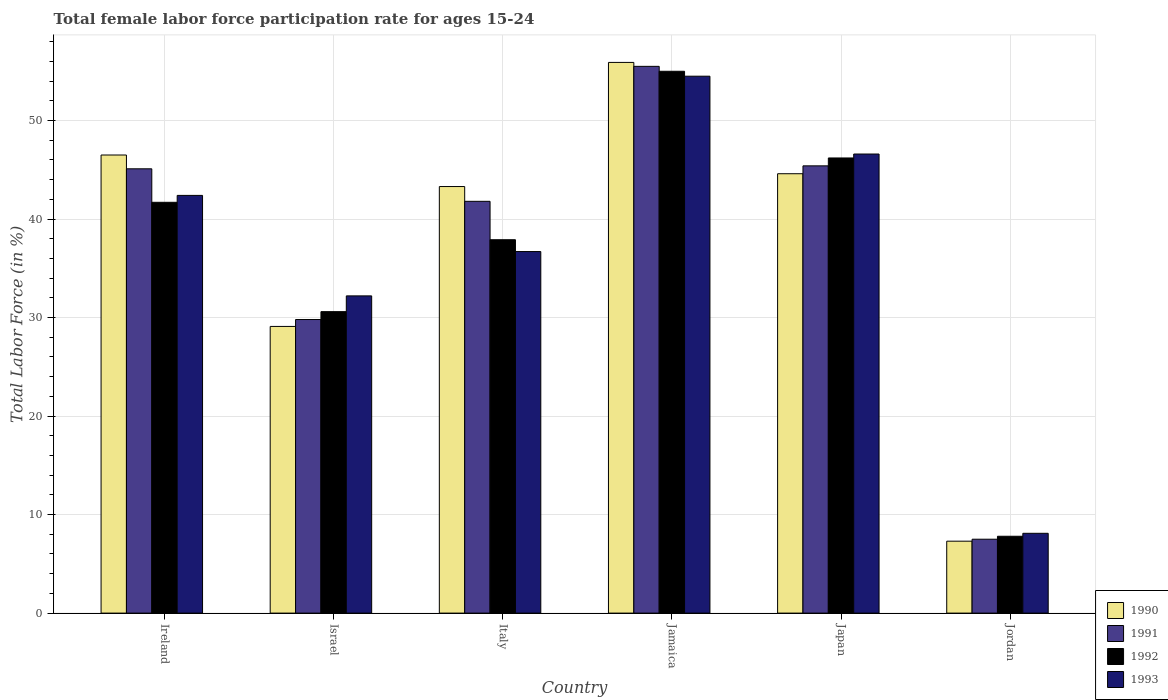How many different coloured bars are there?
Provide a succinct answer. 4. Are the number of bars per tick equal to the number of legend labels?
Ensure brevity in your answer.  Yes. Are the number of bars on each tick of the X-axis equal?
Provide a short and direct response. Yes. How many bars are there on the 5th tick from the right?
Offer a very short reply. 4. What is the label of the 4th group of bars from the left?
Your answer should be compact. Jamaica. What is the female labor force participation rate in 1991 in Japan?
Ensure brevity in your answer.  45.4. Across all countries, what is the maximum female labor force participation rate in 1993?
Your response must be concise. 54.5. Across all countries, what is the minimum female labor force participation rate in 1990?
Ensure brevity in your answer.  7.3. In which country was the female labor force participation rate in 1991 maximum?
Your answer should be compact. Jamaica. In which country was the female labor force participation rate in 1990 minimum?
Give a very brief answer. Jordan. What is the total female labor force participation rate in 1991 in the graph?
Make the answer very short. 225.1. What is the difference between the female labor force participation rate in 1991 in Italy and that in Japan?
Keep it short and to the point. -3.6. What is the difference between the female labor force participation rate in 1991 in Israel and the female labor force participation rate in 1990 in Italy?
Your response must be concise. -13.5. What is the average female labor force participation rate in 1991 per country?
Provide a short and direct response. 37.52. In how many countries, is the female labor force participation rate in 1991 greater than 14 %?
Offer a very short reply. 5. What is the ratio of the female labor force participation rate in 1990 in Ireland to that in Japan?
Give a very brief answer. 1.04. Is the female labor force participation rate in 1993 in Ireland less than that in Jamaica?
Keep it short and to the point. Yes. What is the difference between the highest and the second highest female labor force participation rate in 1993?
Make the answer very short. 4.2. In how many countries, is the female labor force participation rate in 1992 greater than the average female labor force participation rate in 1992 taken over all countries?
Offer a very short reply. 4. Is it the case that in every country, the sum of the female labor force participation rate in 1990 and female labor force participation rate in 1993 is greater than the sum of female labor force participation rate in 1992 and female labor force participation rate in 1991?
Keep it short and to the point. No. What does the 2nd bar from the left in Japan represents?
Your answer should be compact. 1991. How many bars are there?
Your answer should be very brief. 24. Are all the bars in the graph horizontal?
Offer a terse response. No. How many countries are there in the graph?
Ensure brevity in your answer.  6. What is the difference between two consecutive major ticks on the Y-axis?
Provide a short and direct response. 10. Are the values on the major ticks of Y-axis written in scientific E-notation?
Your response must be concise. No. Does the graph contain any zero values?
Keep it short and to the point. No. How are the legend labels stacked?
Your response must be concise. Vertical. What is the title of the graph?
Ensure brevity in your answer.  Total female labor force participation rate for ages 15-24. What is the Total Labor Force (in %) in 1990 in Ireland?
Make the answer very short. 46.5. What is the Total Labor Force (in %) in 1991 in Ireland?
Your response must be concise. 45.1. What is the Total Labor Force (in %) in 1992 in Ireland?
Your response must be concise. 41.7. What is the Total Labor Force (in %) of 1993 in Ireland?
Your answer should be compact. 42.4. What is the Total Labor Force (in %) of 1990 in Israel?
Give a very brief answer. 29.1. What is the Total Labor Force (in %) of 1991 in Israel?
Your answer should be compact. 29.8. What is the Total Labor Force (in %) in 1992 in Israel?
Offer a terse response. 30.6. What is the Total Labor Force (in %) in 1993 in Israel?
Your answer should be very brief. 32.2. What is the Total Labor Force (in %) of 1990 in Italy?
Offer a very short reply. 43.3. What is the Total Labor Force (in %) of 1991 in Italy?
Ensure brevity in your answer.  41.8. What is the Total Labor Force (in %) of 1992 in Italy?
Give a very brief answer. 37.9. What is the Total Labor Force (in %) in 1993 in Italy?
Ensure brevity in your answer.  36.7. What is the Total Labor Force (in %) of 1990 in Jamaica?
Make the answer very short. 55.9. What is the Total Labor Force (in %) of 1991 in Jamaica?
Offer a very short reply. 55.5. What is the Total Labor Force (in %) in 1992 in Jamaica?
Ensure brevity in your answer.  55. What is the Total Labor Force (in %) in 1993 in Jamaica?
Keep it short and to the point. 54.5. What is the Total Labor Force (in %) of 1990 in Japan?
Offer a terse response. 44.6. What is the Total Labor Force (in %) in 1991 in Japan?
Give a very brief answer. 45.4. What is the Total Labor Force (in %) of 1992 in Japan?
Ensure brevity in your answer.  46.2. What is the Total Labor Force (in %) in 1993 in Japan?
Offer a very short reply. 46.6. What is the Total Labor Force (in %) of 1990 in Jordan?
Give a very brief answer. 7.3. What is the Total Labor Force (in %) in 1991 in Jordan?
Keep it short and to the point. 7.5. What is the Total Labor Force (in %) of 1992 in Jordan?
Your answer should be compact. 7.8. What is the Total Labor Force (in %) in 1993 in Jordan?
Give a very brief answer. 8.1. Across all countries, what is the maximum Total Labor Force (in %) of 1990?
Your answer should be very brief. 55.9. Across all countries, what is the maximum Total Labor Force (in %) in 1991?
Provide a succinct answer. 55.5. Across all countries, what is the maximum Total Labor Force (in %) of 1992?
Your answer should be very brief. 55. Across all countries, what is the maximum Total Labor Force (in %) in 1993?
Keep it short and to the point. 54.5. Across all countries, what is the minimum Total Labor Force (in %) in 1990?
Your response must be concise. 7.3. Across all countries, what is the minimum Total Labor Force (in %) of 1992?
Offer a very short reply. 7.8. Across all countries, what is the minimum Total Labor Force (in %) of 1993?
Offer a very short reply. 8.1. What is the total Total Labor Force (in %) in 1990 in the graph?
Offer a very short reply. 226.7. What is the total Total Labor Force (in %) in 1991 in the graph?
Ensure brevity in your answer.  225.1. What is the total Total Labor Force (in %) in 1992 in the graph?
Keep it short and to the point. 219.2. What is the total Total Labor Force (in %) of 1993 in the graph?
Provide a succinct answer. 220.5. What is the difference between the Total Labor Force (in %) of 1991 in Ireland and that in Israel?
Offer a terse response. 15.3. What is the difference between the Total Labor Force (in %) in 1992 in Ireland and that in Israel?
Provide a succinct answer. 11.1. What is the difference between the Total Labor Force (in %) in 1993 in Ireland and that in Israel?
Offer a terse response. 10.2. What is the difference between the Total Labor Force (in %) of 1991 in Ireland and that in Italy?
Make the answer very short. 3.3. What is the difference between the Total Labor Force (in %) of 1993 in Ireland and that in Italy?
Your answer should be very brief. 5.7. What is the difference between the Total Labor Force (in %) of 1991 in Ireland and that in Jamaica?
Keep it short and to the point. -10.4. What is the difference between the Total Labor Force (in %) of 1992 in Ireland and that in Jamaica?
Your response must be concise. -13.3. What is the difference between the Total Labor Force (in %) of 1993 in Ireland and that in Jamaica?
Ensure brevity in your answer.  -12.1. What is the difference between the Total Labor Force (in %) in 1992 in Ireland and that in Japan?
Ensure brevity in your answer.  -4.5. What is the difference between the Total Labor Force (in %) of 1993 in Ireland and that in Japan?
Offer a terse response. -4.2. What is the difference between the Total Labor Force (in %) in 1990 in Ireland and that in Jordan?
Your response must be concise. 39.2. What is the difference between the Total Labor Force (in %) in 1991 in Ireland and that in Jordan?
Provide a succinct answer. 37.6. What is the difference between the Total Labor Force (in %) in 1992 in Ireland and that in Jordan?
Your answer should be compact. 33.9. What is the difference between the Total Labor Force (in %) of 1993 in Ireland and that in Jordan?
Your response must be concise. 34.3. What is the difference between the Total Labor Force (in %) of 1990 in Israel and that in Italy?
Offer a terse response. -14.2. What is the difference between the Total Labor Force (in %) in 1992 in Israel and that in Italy?
Provide a succinct answer. -7.3. What is the difference between the Total Labor Force (in %) of 1990 in Israel and that in Jamaica?
Keep it short and to the point. -26.8. What is the difference between the Total Labor Force (in %) of 1991 in Israel and that in Jamaica?
Offer a very short reply. -25.7. What is the difference between the Total Labor Force (in %) in 1992 in Israel and that in Jamaica?
Your answer should be very brief. -24.4. What is the difference between the Total Labor Force (in %) of 1993 in Israel and that in Jamaica?
Your response must be concise. -22.3. What is the difference between the Total Labor Force (in %) of 1990 in Israel and that in Japan?
Give a very brief answer. -15.5. What is the difference between the Total Labor Force (in %) of 1991 in Israel and that in Japan?
Give a very brief answer. -15.6. What is the difference between the Total Labor Force (in %) of 1992 in Israel and that in Japan?
Keep it short and to the point. -15.6. What is the difference between the Total Labor Force (in %) of 1993 in Israel and that in Japan?
Your answer should be very brief. -14.4. What is the difference between the Total Labor Force (in %) in 1990 in Israel and that in Jordan?
Ensure brevity in your answer.  21.8. What is the difference between the Total Labor Force (in %) of 1991 in Israel and that in Jordan?
Offer a very short reply. 22.3. What is the difference between the Total Labor Force (in %) of 1992 in Israel and that in Jordan?
Your answer should be very brief. 22.8. What is the difference between the Total Labor Force (in %) of 1993 in Israel and that in Jordan?
Provide a short and direct response. 24.1. What is the difference between the Total Labor Force (in %) in 1991 in Italy and that in Jamaica?
Your response must be concise. -13.7. What is the difference between the Total Labor Force (in %) in 1992 in Italy and that in Jamaica?
Ensure brevity in your answer.  -17.1. What is the difference between the Total Labor Force (in %) in 1993 in Italy and that in Jamaica?
Provide a short and direct response. -17.8. What is the difference between the Total Labor Force (in %) of 1991 in Italy and that in Japan?
Provide a short and direct response. -3.6. What is the difference between the Total Labor Force (in %) in 1993 in Italy and that in Japan?
Ensure brevity in your answer.  -9.9. What is the difference between the Total Labor Force (in %) in 1991 in Italy and that in Jordan?
Your answer should be compact. 34.3. What is the difference between the Total Labor Force (in %) in 1992 in Italy and that in Jordan?
Give a very brief answer. 30.1. What is the difference between the Total Labor Force (in %) of 1993 in Italy and that in Jordan?
Keep it short and to the point. 28.6. What is the difference between the Total Labor Force (in %) of 1990 in Jamaica and that in Japan?
Ensure brevity in your answer.  11.3. What is the difference between the Total Labor Force (in %) in 1993 in Jamaica and that in Japan?
Provide a short and direct response. 7.9. What is the difference between the Total Labor Force (in %) of 1990 in Jamaica and that in Jordan?
Your answer should be very brief. 48.6. What is the difference between the Total Labor Force (in %) of 1992 in Jamaica and that in Jordan?
Your answer should be compact. 47.2. What is the difference between the Total Labor Force (in %) of 1993 in Jamaica and that in Jordan?
Keep it short and to the point. 46.4. What is the difference between the Total Labor Force (in %) in 1990 in Japan and that in Jordan?
Your answer should be compact. 37.3. What is the difference between the Total Labor Force (in %) in 1991 in Japan and that in Jordan?
Your answer should be compact. 37.9. What is the difference between the Total Labor Force (in %) in 1992 in Japan and that in Jordan?
Give a very brief answer. 38.4. What is the difference between the Total Labor Force (in %) of 1993 in Japan and that in Jordan?
Offer a terse response. 38.5. What is the difference between the Total Labor Force (in %) in 1990 in Ireland and the Total Labor Force (in %) in 1991 in Israel?
Your answer should be very brief. 16.7. What is the difference between the Total Labor Force (in %) in 1990 in Ireland and the Total Labor Force (in %) in 1993 in Israel?
Offer a very short reply. 14.3. What is the difference between the Total Labor Force (in %) of 1991 in Ireland and the Total Labor Force (in %) of 1993 in Israel?
Offer a very short reply. 12.9. What is the difference between the Total Labor Force (in %) of 1990 in Ireland and the Total Labor Force (in %) of 1992 in Italy?
Your answer should be very brief. 8.6. What is the difference between the Total Labor Force (in %) of 1991 in Ireland and the Total Labor Force (in %) of 1993 in Italy?
Offer a very short reply. 8.4. What is the difference between the Total Labor Force (in %) of 1990 in Ireland and the Total Labor Force (in %) of 1991 in Jamaica?
Offer a very short reply. -9. What is the difference between the Total Labor Force (in %) of 1990 in Ireland and the Total Labor Force (in %) of 1992 in Jamaica?
Make the answer very short. -8.5. What is the difference between the Total Labor Force (in %) in 1990 in Ireland and the Total Labor Force (in %) in 1993 in Jamaica?
Provide a short and direct response. -8. What is the difference between the Total Labor Force (in %) in 1990 in Ireland and the Total Labor Force (in %) in 1991 in Japan?
Make the answer very short. 1.1. What is the difference between the Total Labor Force (in %) of 1990 in Ireland and the Total Labor Force (in %) of 1993 in Japan?
Ensure brevity in your answer.  -0.1. What is the difference between the Total Labor Force (in %) in 1992 in Ireland and the Total Labor Force (in %) in 1993 in Japan?
Your answer should be compact. -4.9. What is the difference between the Total Labor Force (in %) of 1990 in Ireland and the Total Labor Force (in %) of 1991 in Jordan?
Offer a terse response. 39. What is the difference between the Total Labor Force (in %) of 1990 in Ireland and the Total Labor Force (in %) of 1992 in Jordan?
Provide a succinct answer. 38.7. What is the difference between the Total Labor Force (in %) of 1990 in Ireland and the Total Labor Force (in %) of 1993 in Jordan?
Provide a succinct answer. 38.4. What is the difference between the Total Labor Force (in %) in 1991 in Ireland and the Total Labor Force (in %) in 1992 in Jordan?
Ensure brevity in your answer.  37.3. What is the difference between the Total Labor Force (in %) of 1991 in Ireland and the Total Labor Force (in %) of 1993 in Jordan?
Offer a terse response. 37. What is the difference between the Total Labor Force (in %) of 1992 in Ireland and the Total Labor Force (in %) of 1993 in Jordan?
Keep it short and to the point. 33.6. What is the difference between the Total Labor Force (in %) of 1990 in Israel and the Total Labor Force (in %) of 1993 in Italy?
Give a very brief answer. -7.6. What is the difference between the Total Labor Force (in %) of 1991 in Israel and the Total Labor Force (in %) of 1992 in Italy?
Keep it short and to the point. -8.1. What is the difference between the Total Labor Force (in %) in 1992 in Israel and the Total Labor Force (in %) in 1993 in Italy?
Provide a succinct answer. -6.1. What is the difference between the Total Labor Force (in %) of 1990 in Israel and the Total Labor Force (in %) of 1991 in Jamaica?
Offer a terse response. -26.4. What is the difference between the Total Labor Force (in %) of 1990 in Israel and the Total Labor Force (in %) of 1992 in Jamaica?
Provide a succinct answer. -25.9. What is the difference between the Total Labor Force (in %) of 1990 in Israel and the Total Labor Force (in %) of 1993 in Jamaica?
Provide a short and direct response. -25.4. What is the difference between the Total Labor Force (in %) of 1991 in Israel and the Total Labor Force (in %) of 1992 in Jamaica?
Offer a terse response. -25.2. What is the difference between the Total Labor Force (in %) in 1991 in Israel and the Total Labor Force (in %) in 1993 in Jamaica?
Offer a terse response. -24.7. What is the difference between the Total Labor Force (in %) of 1992 in Israel and the Total Labor Force (in %) of 1993 in Jamaica?
Make the answer very short. -23.9. What is the difference between the Total Labor Force (in %) of 1990 in Israel and the Total Labor Force (in %) of 1991 in Japan?
Offer a terse response. -16.3. What is the difference between the Total Labor Force (in %) of 1990 in Israel and the Total Labor Force (in %) of 1992 in Japan?
Offer a terse response. -17.1. What is the difference between the Total Labor Force (in %) of 1990 in Israel and the Total Labor Force (in %) of 1993 in Japan?
Your answer should be compact. -17.5. What is the difference between the Total Labor Force (in %) of 1991 in Israel and the Total Labor Force (in %) of 1992 in Japan?
Your answer should be very brief. -16.4. What is the difference between the Total Labor Force (in %) in 1991 in Israel and the Total Labor Force (in %) in 1993 in Japan?
Make the answer very short. -16.8. What is the difference between the Total Labor Force (in %) in 1992 in Israel and the Total Labor Force (in %) in 1993 in Japan?
Ensure brevity in your answer.  -16. What is the difference between the Total Labor Force (in %) of 1990 in Israel and the Total Labor Force (in %) of 1991 in Jordan?
Keep it short and to the point. 21.6. What is the difference between the Total Labor Force (in %) of 1990 in Israel and the Total Labor Force (in %) of 1992 in Jordan?
Make the answer very short. 21.3. What is the difference between the Total Labor Force (in %) of 1991 in Israel and the Total Labor Force (in %) of 1993 in Jordan?
Your response must be concise. 21.7. What is the difference between the Total Labor Force (in %) in 1990 in Italy and the Total Labor Force (in %) in 1991 in Jamaica?
Keep it short and to the point. -12.2. What is the difference between the Total Labor Force (in %) in 1990 in Italy and the Total Labor Force (in %) in 1993 in Jamaica?
Provide a succinct answer. -11.2. What is the difference between the Total Labor Force (in %) in 1991 in Italy and the Total Labor Force (in %) in 1992 in Jamaica?
Keep it short and to the point. -13.2. What is the difference between the Total Labor Force (in %) of 1991 in Italy and the Total Labor Force (in %) of 1993 in Jamaica?
Ensure brevity in your answer.  -12.7. What is the difference between the Total Labor Force (in %) in 1992 in Italy and the Total Labor Force (in %) in 1993 in Jamaica?
Provide a short and direct response. -16.6. What is the difference between the Total Labor Force (in %) of 1990 in Italy and the Total Labor Force (in %) of 1993 in Japan?
Ensure brevity in your answer.  -3.3. What is the difference between the Total Labor Force (in %) in 1991 in Italy and the Total Labor Force (in %) in 1992 in Japan?
Your response must be concise. -4.4. What is the difference between the Total Labor Force (in %) of 1991 in Italy and the Total Labor Force (in %) of 1993 in Japan?
Keep it short and to the point. -4.8. What is the difference between the Total Labor Force (in %) of 1990 in Italy and the Total Labor Force (in %) of 1991 in Jordan?
Your answer should be compact. 35.8. What is the difference between the Total Labor Force (in %) in 1990 in Italy and the Total Labor Force (in %) in 1992 in Jordan?
Keep it short and to the point. 35.5. What is the difference between the Total Labor Force (in %) of 1990 in Italy and the Total Labor Force (in %) of 1993 in Jordan?
Give a very brief answer. 35.2. What is the difference between the Total Labor Force (in %) in 1991 in Italy and the Total Labor Force (in %) in 1992 in Jordan?
Your answer should be compact. 34. What is the difference between the Total Labor Force (in %) in 1991 in Italy and the Total Labor Force (in %) in 1993 in Jordan?
Your answer should be compact. 33.7. What is the difference between the Total Labor Force (in %) in 1992 in Italy and the Total Labor Force (in %) in 1993 in Jordan?
Your answer should be very brief. 29.8. What is the difference between the Total Labor Force (in %) in 1990 in Jamaica and the Total Labor Force (in %) in 1991 in Jordan?
Give a very brief answer. 48.4. What is the difference between the Total Labor Force (in %) in 1990 in Jamaica and the Total Labor Force (in %) in 1992 in Jordan?
Your answer should be very brief. 48.1. What is the difference between the Total Labor Force (in %) in 1990 in Jamaica and the Total Labor Force (in %) in 1993 in Jordan?
Offer a very short reply. 47.8. What is the difference between the Total Labor Force (in %) of 1991 in Jamaica and the Total Labor Force (in %) of 1992 in Jordan?
Make the answer very short. 47.7. What is the difference between the Total Labor Force (in %) of 1991 in Jamaica and the Total Labor Force (in %) of 1993 in Jordan?
Make the answer very short. 47.4. What is the difference between the Total Labor Force (in %) of 1992 in Jamaica and the Total Labor Force (in %) of 1993 in Jordan?
Ensure brevity in your answer.  46.9. What is the difference between the Total Labor Force (in %) of 1990 in Japan and the Total Labor Force (in %) of 1991 in Jordan?
Ensure brevity in your answer.  37.1. What is the difference between the Total Labor Force (in %) of 1990 in Japan and the Total Labor Force (in %) of 1992 in Jordan?
Keep it short and to the point. 36.8. What is the difference between the Total Labor Force (in %) of 1990 in Japan and the Total Labor Force (in %) of 1993 in Jordan?
Make the answer very short. 36.5. What is the difference between the Total Labor Force (in %) of 1991 in Japan and the Total Labor Force (in %) of 1992 in Jordan?
Give a very brief answer. 37.6. What is the difference between the Total Labor Force (in %) of 1991 in Japan and the Total Labor Force (in %) of 1993 in Jordan?
Your answer should be compact. 37.3. What is the difference between the Total Labor Force (in %) in 1992 in Japan and the Total Labor Force (in %) in 1993 in Jordan?
Make the answer very short. 38.1. What is the average Total Labor Force (in %) of 1990 per country?
Your answer should be compact. 37.78. What is the average Total Labor Force (in %) in 1991 per country?
Make the answer very short. 37.52. What is the average Total Labor Force (in %) of 1992 per country?
Make the answer very short. 36.53. What is the average Total Labor Force (in %) in 1993 per country?
Your answer should be compact. 36.75. What is the difference between the Total Labor Force (in %) in 1990 and Total Labor Force (in %) in 1992 in Ireland?
Offer a terse response. 4.8. What is the difference between the Total Labor Force (in %) of 1990 and Total Labor Force (in %) of 1993 in Ireland?
Ensure brevity in your answer.  4.1. What is the difference between the Total Labor Force (in %) of 1991 and Total Labor Force (in %) of 1992 in Ireland?
Keep it short and to the point. 3.4. What is the difference between the Total Labor Force (in %) of 1991 and Total Labor Force (in %) of 1993 in Ireland?
Ensure brevity in your answer.  2.7. What is the difference between the Total Labor Force (in %) of 1990 and Total Labor Force (in %) of 1991 in Israel?
Offer a very short reply. -0.7. What is the difference between the Total Labor Force (in %) in 1992 and Total Labor Force (in %) in 1993 in Israel?
Your answer should be very brief. -1.6. What is the difference between the Total Labor Force (in %) in 1990 and Total Labor Force (in %) in 1992 in Italy?
Provide a succinct answer. 5.4. What is the difference between the Total Labor Force (in %) in 1990 and Total Labor Force (in %) in 1993 in Italy?
Your response must be concise. 6.6. What is the difference between the Total Labor Force (in %) in 1991 and Total Labor Force (in %) in 1992 in Italy?
Make the answer very short. 3.9. What is the difference between the Total Labor Force (in %) of 1991 and Total Labor Force (in %) of 1993 in Italy?
Your answer should be compact. 5.1. What is the difference between the Total Labor Force (in %) in 1990 and Total Labor Force (in %) in 1991 in Jamaica?
Give a very brief answer. 0.4. What is the difference between the Total Labor Force (in %) of 1990 and Total Labor Force (in %) of 1992 in Jamaica?
Your answer should be compact. 0.9. What is the difference between the Total Labor Force (in %) of 1990 and Total Labor Force (in %) of 1993 in Jamaica?
Your response must be concise. 1.4. What is the difference between the Total Labor Force (in %) of 1991 and Total Labor Force (in %) of 1993 in Jamaica?
Offer a very short reply. 1. What is the difference between the Total Labor Force (in %) of 1990 and Total Labor Force (in %) of 1991 in Japan?
Your response must be concise. -0.8. What is the difference between the Total Labor Force (in %) in 1991 and Total Labor Force (in %) in 1992 in Japan?
Make the answer very short. -0.8. What is the difference between the Total Labor Force (in %) of 1991 and Total Labor Force (in %) of 1993 in Japan?
Give a very brief answer. -1.2. What is the difference between the Total Labor Force (in %) in 1992 and Total Labor Force (in %) in 1993 in Japan?
Give a very brief answer. -0.4. What is the difference between the Total Labor Force (in %) of 1991 and Total Labor Force (in %) of 1992 in Jordan?
Make the answer very short. -0.3. What is the difference between the Total Labor Force (in %) in 1991 and Total Labor Force (in %) in 1993 in Jordan?
Offer a very short reply. -0.6. What is the difference between the Total Labor Force (in %) of 1992 and Total Labor Force (in %) of 1993 in Jordan?
Provide a succinct answer. -0.3. What is the ratio of the Total Labor Force (in %) of 1990 in Ireland to that in Israel?
Your answer should be very brief. 1.6. What is the ratio of the Total Labor Force (in %) in 1991 in Ireland to that in Israel?
Give a very brief answer. 1.51. What is the ratio of the Total Labor Force (in %) in 1992 in Ireland to that in Israel?
Keep it short and to the point. 1.36. What is the ratio of the Total Labor Force (in %) of 1993 in Ireland to that in Israel?
Your answer should be compact. 1.32. What is the ratio of the Total Labor Force (in %) in 1990 in Ireland to that in Italy?
Ensure brevity in your answer.  1.07. What is the ratio of the Total Labor Force (in %) in 1991 in Ireland to that in Italy?
Give a very brief answer. 1.08. What is the ratio of the Total Labor Force (in %) of 1992 in Ireland to that in Italy?
Provide a short and direct response. 1.1. What is the ratio of the Total Labor Force (in %) of 1993 in Ireland to that in Italy?
Your response must be concise. 1.16. What is the ratio of the Total Labor Force (in %) in 1990 in Ireland to that in Jamaica?
Your answer should be very brief. 0.83. What is the ratio of the Total Labor Force (in %) of 1991 in Ireland to that in Jamaica?
Provide a succinct answer. 0.81. What is the ratio of the Total Labor Force (in %) in 1992 in Ireland to that in Jamaica?
Offer a terse response. 0.76. What is the ratio of the Total Labor Force (in %) of 1993 in Ireland to that in Jamaica?
Your response must be concise. 0.78. What is the ratio of the Total Labor Force (in %) of 1990 in Ireland to that in Japan?
Your answer should be very brief. 1.04. What is the ratio of the Total Labor Force (in %) of 1992 in Ireland to that in Japan?
Provide a short and direct response. 0.9. What is the ratio of the Total Labor Force (in %) in 1993 in Ireland to that in Japan?
Your response must be concise. 0.91. What is the ratio of the Total Labor Force (in %) in 1990 in Ireland to that in Jordan?
Your answer should be compact. 6.37. What is the ratio of the Total Labor Force (in %) in 1991 in Ireland to that in Jordan?
Keep it short and to the point. 6.01. What is the ratio of the Total Labor Force (in %) in 1992 in Ireland to that in Jordan?
Keep it short and to the point. 5.35. What is the ratio of the Total Labor Force (in %) of 1993 in Ireland to that in Jordan?
Your answer should be compact. 5.23. What is the ratio of the Total Labor Force (in %) of 1990 in Israel to that in Italy?
Your answer should be compact. 0.67. What is the ratio of the Total Labor Force (in %) in 1991 in Israel to that in Italy?
Offer a terse response. 0.71. What is the ratio of the Total Labor Force (in %) in 1992 in Israel to that in Italy?
Your answer should be very brief. 0.81. What is the ratio of the Total Labor Force (in %) in 1993 in Israel to that in Italy?
Provide a short and direct response. 0.88. What is the ratio of the Total Labor Force (in %) of 1990 in Israel to that in Jamaica?
Make the answer very short. 0.52. What is the ratio of the Total Labor Force (in %) in 1991 in Israel to that in Jamaica?
Your response must be concise. 0.54. What is the ratio of the Total Labor Force (in %) of 1992 in Israel to that in Jamaica?
Your answer should be very brief. 0.56. What is the ratio of the Total Labor Force (in %) in 1993 in Israel to that in Jamaica?
Provide a succinct answer. 0.59. What is the ratio of the Total Labor Force (in %) of 1990 in Israel to that in Japan?
Offer a very short reply. 0.65. What is the ratio of the Total Labor Force (in %) of 1991 in Israel to that in Japan?
Provide a succinct answer. 0.66. What is the ratio of the Total Labor Force (in %) of 1992 in Israel to that in Japan?
Your answer should be very brief. 0.66. What is the ratio of the Total Labor Force (in %) in 1993 in Israel to that in Japan?
Make the answer very short. 0.69. What is the ratio of the Total Labor Force (in %) in 1990 in Israel to that in Jordan?
Keep it short and to the point. 3.99. What is the ratio of the Total Labor Force (in %) of 1991 in Israel to that in Jordan?
Provide a short and direct response. 3.97. What is the ratio of the Total Labor Force (in %) in 1992 in Israel to that in Jordan?
Make the answer very short. 3.92. What is the ratio of the Total Labor Force (in %) of 1993 in Israel to that in Jordan?
Offer a terse response. 3.98. What is the ratio of the Total Labor Force (in %) in 1990 in Italy to that in Jamaica?
Your answer should be very brief. 0.77. What is the ratio of the Total Labor Force (in %) in 1991 in Italy to that in Jamaica?
Your answer should be compact. 0.75. What is the ratio of the Total Labor Force (in %) in 1992 in Italy to that in Jamaica?
Your response must be concise. 0.69. What is the ratio of the Total Labor Force (in %) of 1993 in Italy to that in Jamaica?
Offer a very short reply. 0.67. What is the ratio of the Total Labor Force (in %) of 1990 in Italy to that in Japan?
Your answer should be compact. 0.97. What is the ratio of the Total Labor Force (in %) in 1991 in Italy to that in Japan?
Keep it short and to the point. 0.92. What is the ratio of the Total Labor Force (in %) of 1992 in Italy to that in Japan?
Ensure brevity in your answer.  0.82. What is the ratio of the Total Labor Force (in %) of 1993 in Italy to that in Japan?
Keep it short and to the point. 0.79. What is the ratio of the Total Labor Force (in %) of 1990 in Italy to that in Jordan?
Your answer should be very brief. 5.93. What is the ratio of the Total Labor Force (in %) in 1991 in Italy to that in Jordan?
Offer a terse response. 5.57. What is the ratio of the Total Labor Force (in %) of 1992 in Italy to that in Jordan?
Your answer should be very brief. 4.86. What is the ratio of the Total Labor Force (in %) in 1993 in Italy to that in Jordan?
Your answer should be very brief. 4.53. What is the ratio of the Total Labor Force (in %) in 1990 in Jamaica to that in Japan?
Make the answer very short. 1.25. What is the ratio of the Total Labor Force (in %) of 1991 in Jamaica to that in Japan?
Provide a short and direct response. 1.22. What is the ratio of the Total Labor Force (in %) in 1992 in Jamaica to that in Japan?
Your answer should be compact. 1.19. What is the ratio of the Total Labor Force (in %) of 1993 in Jamaica to that in Japan?
Give a very brief answer. 1.17. What is the ratio of the Total Labor Force (in %) in 1990 in Jamaica to that in Jordan?
Your response must be concise. 7.66. What is the ratio of the Total Labor Force (in %) in 1992 in Jamaica to that in Jordan?
Make the answer very short. 7.05. What is the ratio of the Total Labor Force (in %) in 1993 in Jamaica to that in Jordan?
Keep it short and to the point. 6.73. What is the ratio of the Total Labor Force (in %) of 1990 in Japan to that in Jordan?
Keep it short and to the point. 6.11. What is the ratio of the Total Labor Force (in %) in 1991 in Japan to that in Jordan?
Make the answer very short. 6.05. What is the ratio of the Total Labor Force (in %) in 1992 in Japan to that in Jordan?
Keep it short and to the point. 5.92. What is the ratio of the Total Labor Force (in %) of 1993 in Japan to that in Jordan?
Make the answer very short. 5.75. What is the difference between the highest and the second highest Total Labor Force (in %) in 1991?
Your answer should be very brief. 10.1. What is the difference between the highest and the lowest Total Labor Force (in %) in 1990?
Your response must be concise. 48.6. What is the difference between the highest and the lowest Total Labor Force (in %) in 1991?
Your answer should be compact. 48. What is the difference between the highest and the lowest Total Labor Force (in %) of 1992?
Your answer should be compact. 47.2. What is the difference between the highest and the lowest Total Labor Force (in %) in 1993?
Provide a succinct answer. 46.4. 